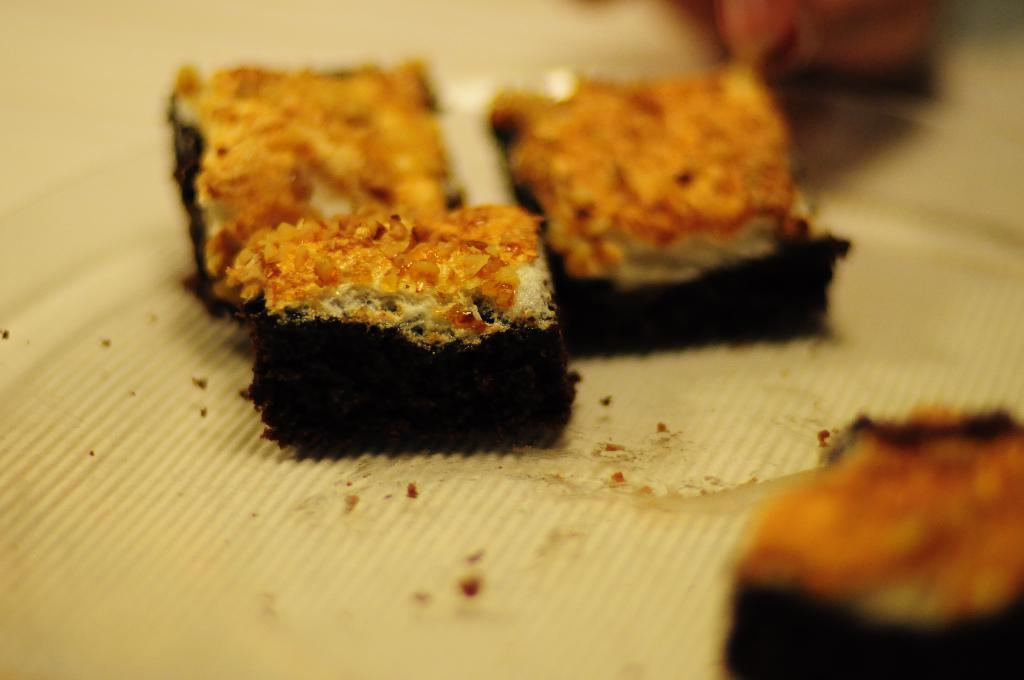What type of food items can be seen in the image? The food items resemble cake. How are the food items arranged in the image? The food items are placed on a white colored cloth. How many houses can be seen in the image? There are no houses present in the image. What type of thrill can be experienced by eating the cake in the image? The image does not convey any information about the taste or experience of eating the cake, so it's not possible to determine what type of thrill might be experienced. 